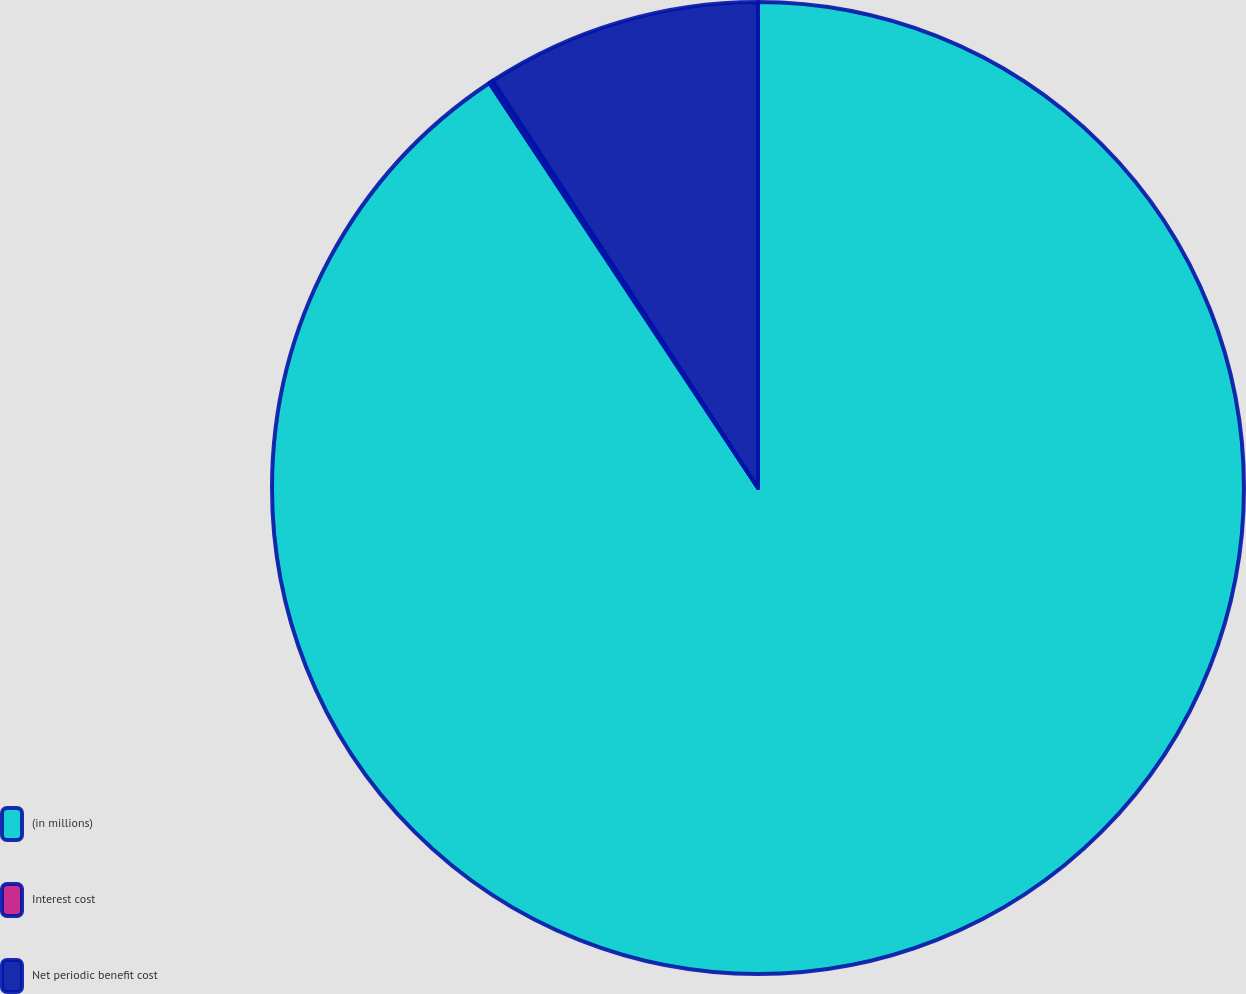Convert chart. <chart><loc_0><loc_0><loc_500><loc_500><pie_chart><fcel>(in millions)<fcel>Interest cost<fcel>Net periodic benefit cost<nl><fcel>90.68%<fcel>0.13%<fcel>9.19%<nl></chart> 